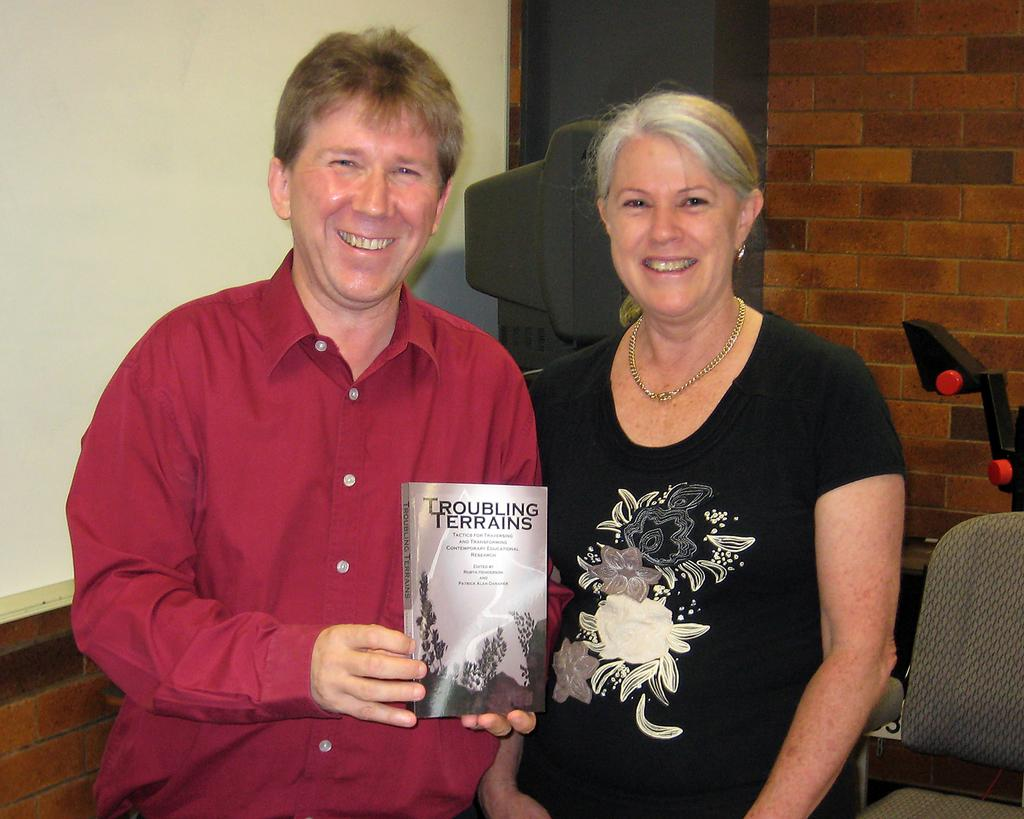<image>
Give a short and clear explanation of the subsequent image. A man is holding up a book titled Troubling Terrains. 